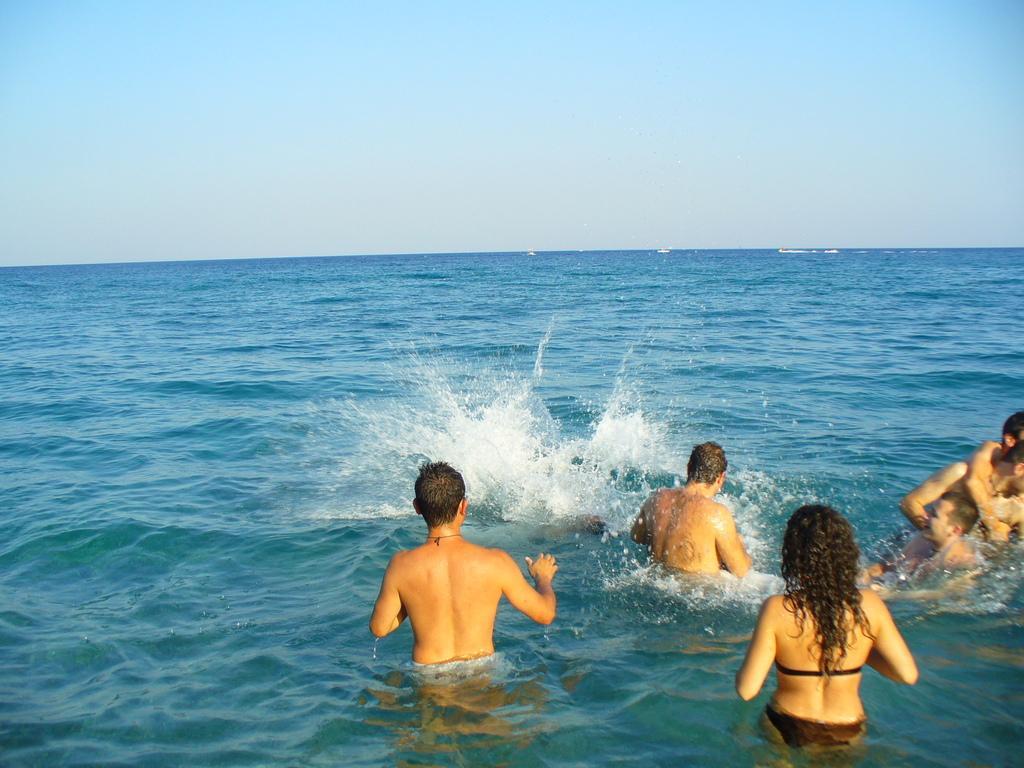Please provide a concise description of this image. In this picture there is a group of men and women playing and enjoying in the seawater. Behind there is a sea water and above a clear blue sky. 